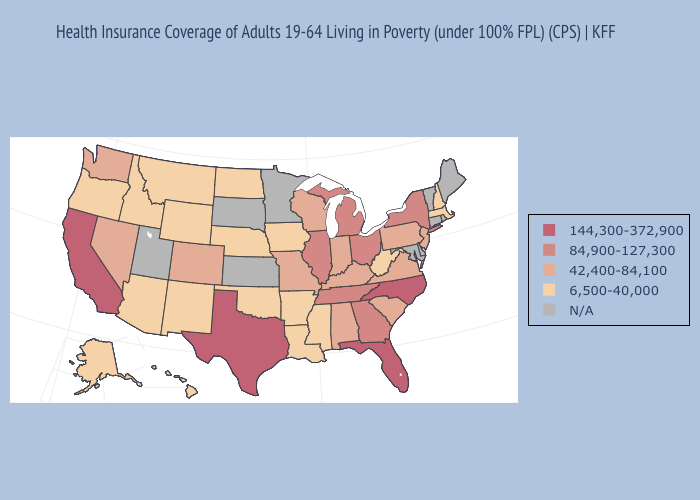Does the map have missing data?
Quick response, please. Yes. How many symbols are there in the legend?
Concise answer only. 5. What is the lowest value in states that border Arkansas?
Write a very short answer. 6,500-40,000. Does Texas have the lowest value in the South?
Concise answer only. No. What is the lowest value in the South?
Be succinct. 6,500-40,000. Name the states that have a value in the range 42,400-84,100?
Concise answer only. Alabama, Colorado, Indiana, Kentucky, Missouri, Nevada, New Jersey, Pennsylvania, South Carolina, Virginia, Washington, Wisconsin. What is the value of Hawaii?
Short answer required. 6,500-40,000. What is the highest value in the USA?
Be succinct. 144,300-372,900. What is the value of Ohio?
Quick response, please. 84,900-127,300. Among the states that border Missouri , which have the highest value?
Be succinct. Illinois, Tennessee. What is the lowest value in the MidWest?
Answer briefly. 6,500-40,000. Name the states that have a value in the range N/A?
Keep it brief. Connecticut, Delaware, Kansas, Maine, Maryland, Minnesota, Rhode Island, South Dakota, Utah, Vermont. What is the value of Arkansas?
Quick response, please. 6,500-40,000. What is the value of Oklahoma?
Quick response, please. 6,500-40,000. 